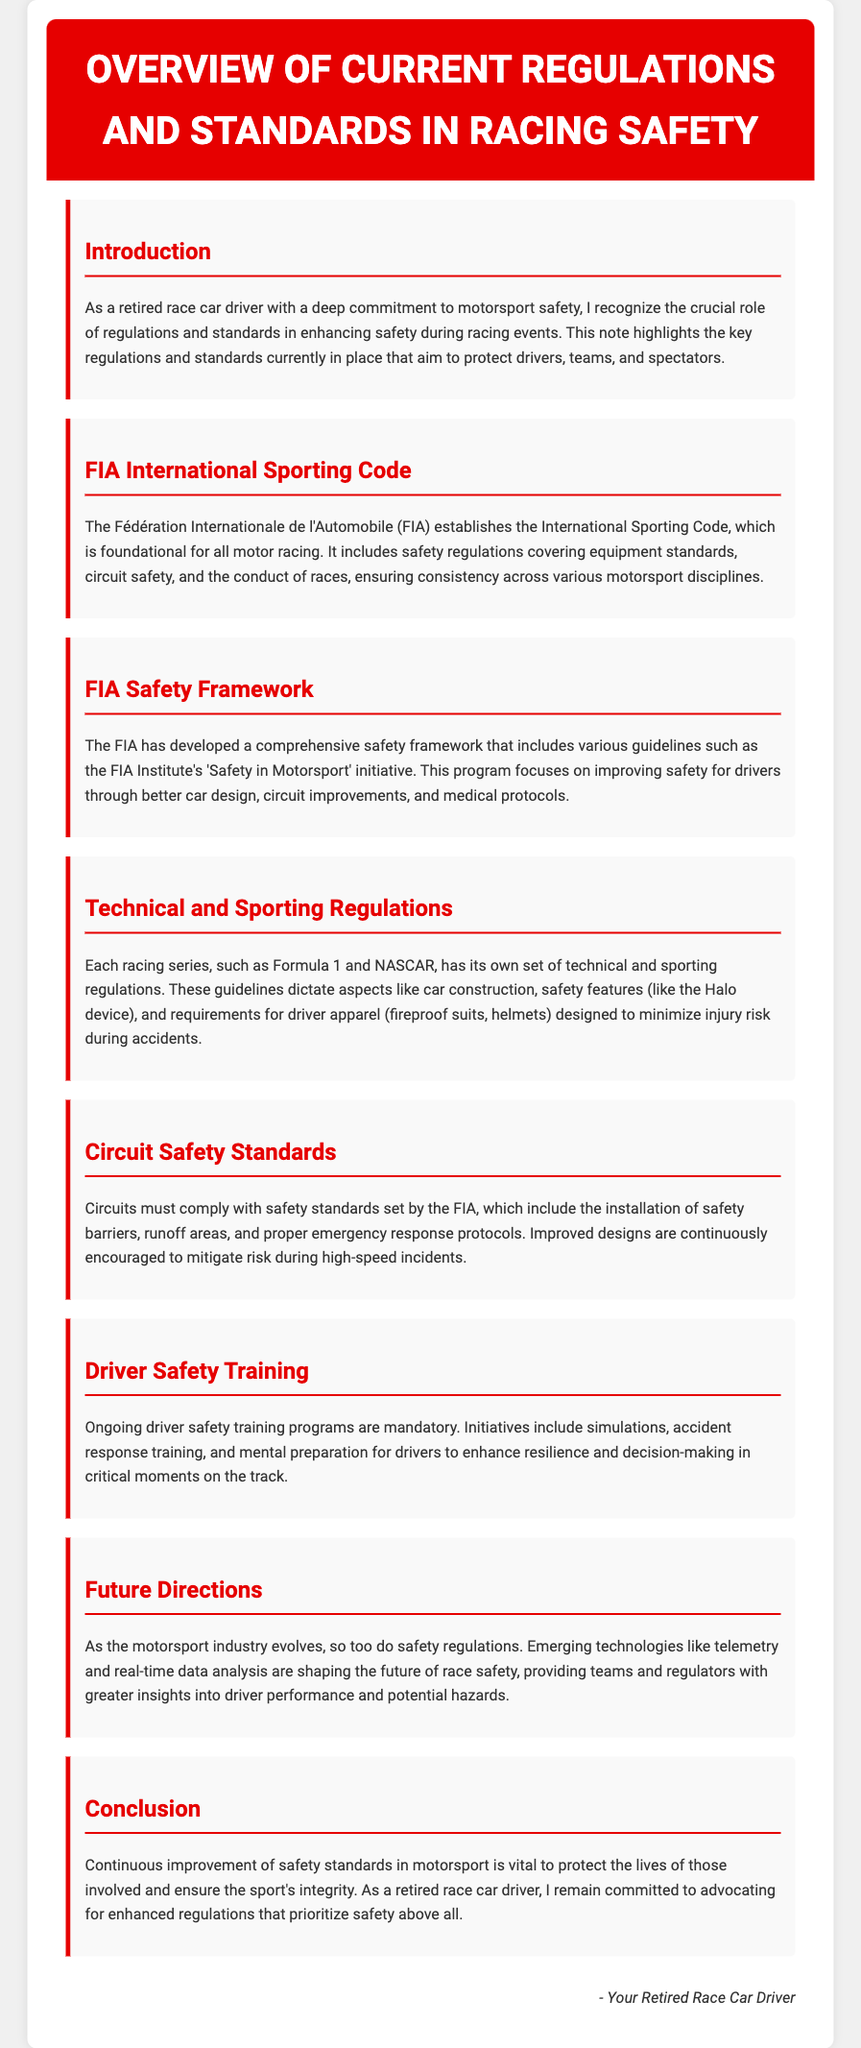What is the title of the document? The title of the document is stated in the header section, referring to the regulations and standards in racing safety.
Answer: Overview of Current Regulations and Standards in Racing Safety What organization established the International Sporting Code? The document mentions the organization responsible for the International Sporting Code within the context of motor racing regulations.
Answer: Fédération Internationale de l'Automobile What is one of the key focuses of the FIA Institute's 'Safety in Motorsport' initiative? The document lists several initiatives of the FIA Institute, specifically focusing on a crucial aspect of driver safety.
Answer: Better car design What are drivers required to wear for safety? The document outlines requirements for driver apparel designed to mitigate injury risk, mentioning specific items.
Answer: Fireproof suits, helmets What must circuits comply with according to the FIA? The document refers to specific compliance requirements that circuits must meet under FIA standards.
Answer: Safety standards What kind of training is mandatory for drivers? The document highlights the types of training that are required to enhance driver safety and decision-making.
Answer: Ongoing driver safety training programs How are circuit safety measures continuously improved? The document discusses the approach to enhancing circuit safety standards and the encouragement for new designs.
Answer: Improved designs What technologies are shaping the future of race safety? The document mentions emerging technologies that contribute to advancements in racing safety.
Answer: Telemetry and real-time data analysis Why is continuous improvement of safety standards vital? The document concludes with a reason for the importance of safety standards in motorsport.
Answer: To protect lives and ensure the sport's integrity 